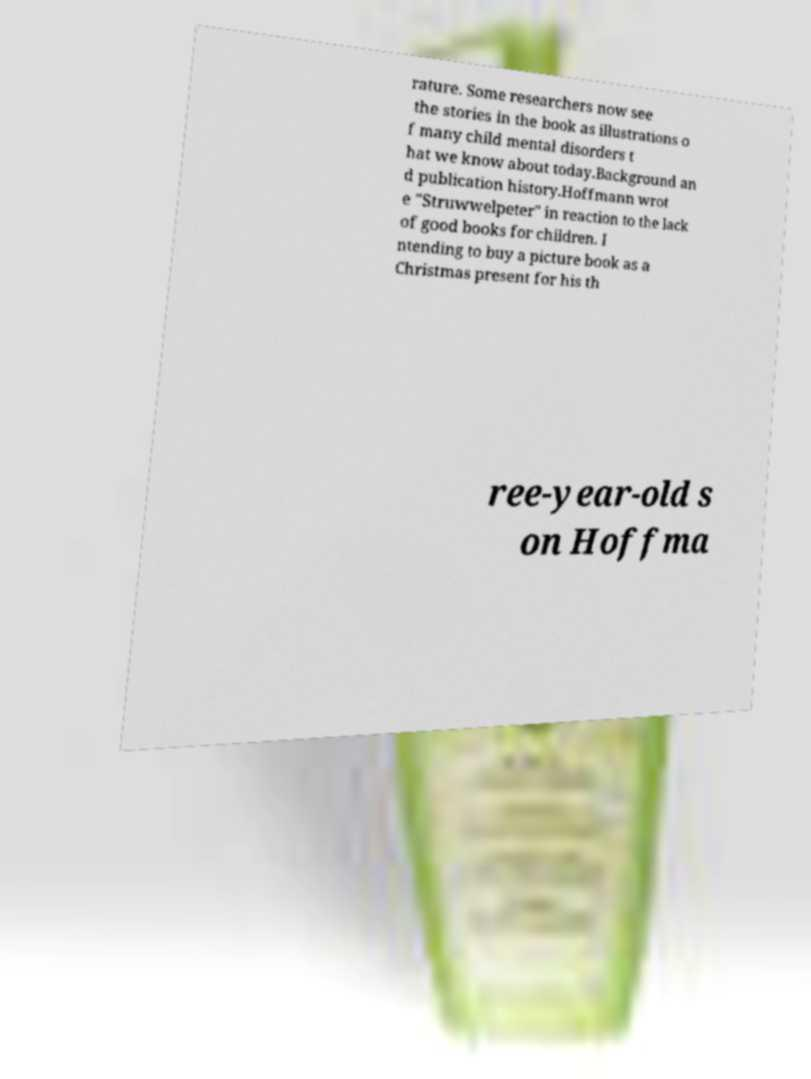There's text embedded in this image that I need extracted. Can you transcribe it verbatim? rature. Some researchers now see the stories in the book as illustrations o f many child mental disorders t hat we know about today.Background an d publication history.Hoffmann wrot e "Struwwelpeter" in reaction to the lack of good books for children. I ntending to buy a picture book as a Christmas present for his th ree-year-old s on Hoffma 